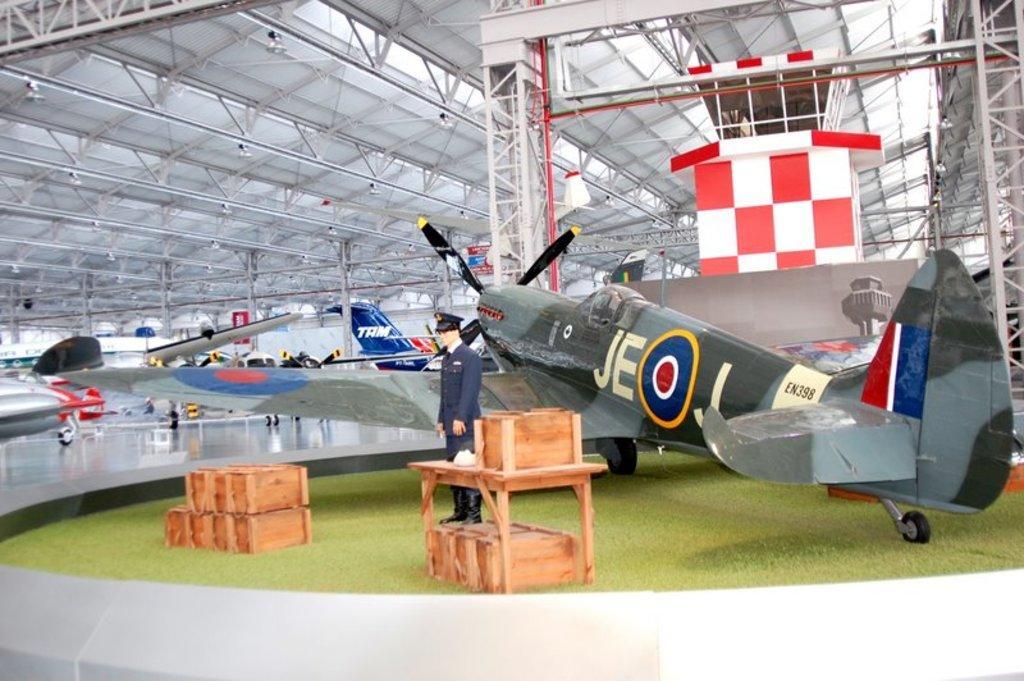How would you summarize this image in a sentence or two? In this image I can see the ground, few wooden boxes, a person wearing uniform is standing and a aircraft which is grey, green, blue, red, white and cream in color is on the ground. In the background I can see few other aircrafts on the ground, the ceiling and an object which is red and white in color. 